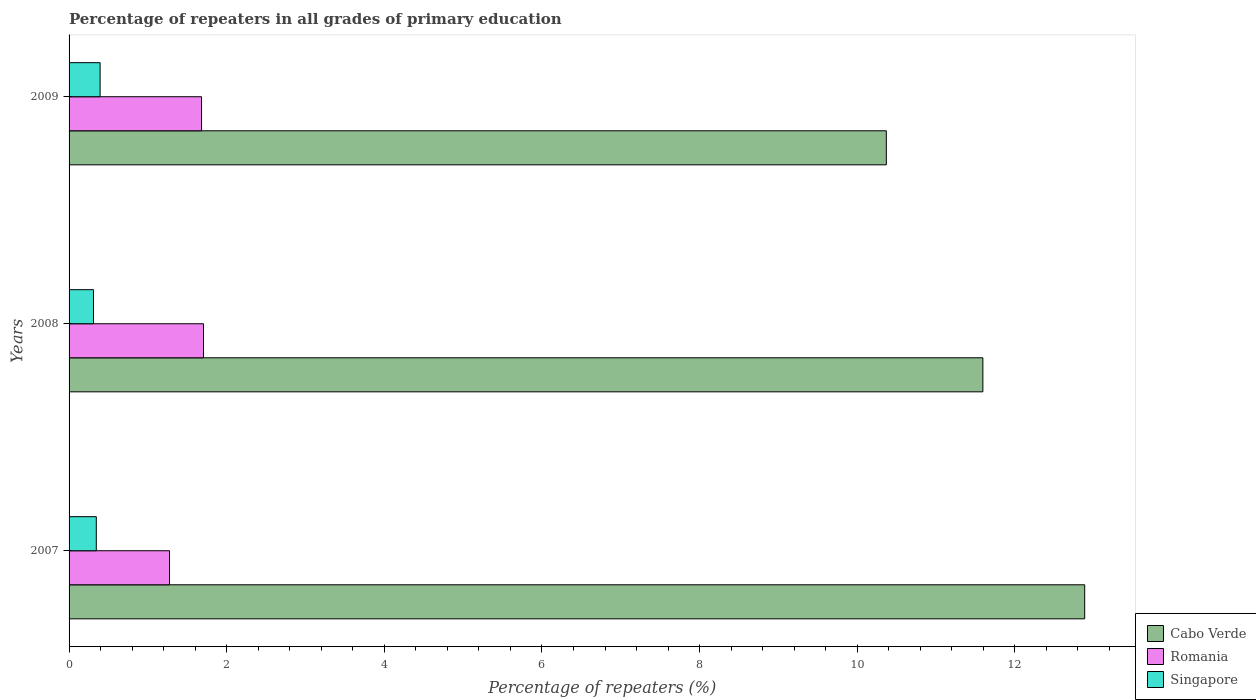How many different coloured bars are there?
Your answer should be compact. 3. How many bars are there on the 2nd tick from the top?
Provide a succinct answer. 3. In how many cases, is the number of bars for a given year not equal to the number of legend labels?
Provide a succinct answer. 0. What is the percentage of repeaters in Romania in 2007?
Provide a short and direct response. 1.27. Across all years, what is the maximum percentage of repeaters in Romania?
Offer a very short reply. 1.71. Across all years, what is the minimum percentage of repeaters in Romania?
Make the answer very short. 1.27. In which year was the percentage of repeaters in Romania maximum?
Offer a very short reply. 2008. In which year was the percentage of repeaters in Singapore minimum?
Offer a terse response. 2008. What is the total percentage of repeaters in Cabo Verde in the graph?
Offer a terse response. 34.85. What is the difference between the percentage of repeaters in Cabo Verde in 2008 and that in 2009?
Your answer should be very brief. 1.23. What is the difference between the percentage of repeaters in Singapore in 2009 and the percentage of repeaters in Cabo Verde in 2007?
Make the answer very short. -12.49. What is the average percentage of repeaters in Romania per year?
Offer a terse response. 1.55. In the year 2008, what is the difference between the percentage of repeaters in Cabo Verde and percentage of repeaters in Singapore?
Ensure brevity in your answer.  11.28. In how many years, is the percentage of repeaters in Cabo Verde greater than 11.2 %?
Ensure brevity in your answer.  2. What is the ratio of the percentage of repeaters in Romania in 2007 to that in 2009?
Keep it short and to the point. 0.76. Is the percentage of repeaters in Cabo Verde in 2007 less than that in 2008?
Your response must be concise. No. What is the difference between the highest and the second highest percentage of repeaters in Cabo Verde?
Your answer should be very brief. 1.29. What is the difference between the highest and the lowest percentage of repeaters in Romania?
Give a very brief answer. 0.43. Is the sum of the percentage of repeaters in Singapore in 2008 and 2009 greater than the maximum percentage of repeaters in Cabo Verde across all years?
Your answer should be compact. No. What does the 1st bar from the top in 2008 represents?
Your response must be concise. Singapore. What does the 3rd bar from the bottom in 2009 represents?
Offer a terse response. Singapore. Are all the bars in the graph horizontal?
Provide a short and direct response. Yes. What is the difference between two consecutive major ticks on the X-axis?
Keep it short and to the point. 2. Are the values on the major ticks of X-axis written in scientific E-notation?
Offer a very short reply. No. Does the graph contain any zero values?
Provide a succinct answer. No. How many legend labels are there?
Your answer should be very brief. 3. How are the legend labels stacked?
Your answer should be compact. Vertical. What is the title of the graph?
Provide a short and direct response. Percentage of repeaters in all grades of primary education. Does "Pakistan" appear as one of the legend labels in the graph?
Keep it short and to the point. No. What is the label or title of the X-axis?
Give a very brief answer. Percentage of repeaters (%). What is the label or title of the Y-axis?
Ensure brevity in your answer.  Years. What is the Percentage of repeaters (%) in Cabo Verde in 2007?
Your response must be concise. 12.89. What is the Percentage of repeaters (%) in Romania in 2007?
Your response must be concise. 1.27. What is the Percentage of repeaters (%) in Singapore in 2007?
Give a very brief answer. 0.35. What is the Percentage of repeaters (%) in Cabo Verde in 2008?
Offer a terse response. 11.59. What is the Percentage of repeaters (%) in Romania in 2008?
Ensure brevity in your answer.  1.71. What is the Percentage of repeaters (%) in Singapore in 2008?
Offer a very short reply. 0.31. What is the Percentage of repeaters (%) in Cabo Verde in 2009?
Provide a succinct answer. 10.37. What is the Percentage of repeaters (%) in Romania in 2009?
Keep it short and to the point. 1.68. What is the Percentage of repeaters (%) of Singapore in 2009?
Your answer should be very brief. 0.39. Across all years, what is the maximum Percentage of repeaters (%) of Cabo Verde?
Your answer should be compact. 12.89. Across all years, what is the maximum Percentage of repeaters (%) of Romania?
Offer a very short reply. 1.71. Across all years, what is the maximum Percentage of repeaters (%) of Singapore?
Give a very brief answer. 0.39. Across all years, what is the minimum Percentage of repeaters (%) in Cabo Verde?
Your answer should be very brief. 10.37. Across all years, what is the minimum Percentage of repeaters (%) in Romania?
Offer a very short reply. 1.27. Across all years, what is the minimum Percentage of repeaters (%) of Singapore?
Provide a short and direct response. 0.31. What is the total Percentage of repeaters (%) of Cabo Verde in the graph?
Offer a terse response. 34.85. What is the total Percentage of repeaters (%) in Romania in the graph?
Provide a succinct answer. 4.66. What is the total Percentage of repeaters (%) of Singapore in the graph?
Keep it short and to the point. 1.05. What is the difference between the Percentage of repeaters (%) in Cabo Verde in 2007 and that in 2008?
Ensure brevity in your answer.  1.29. What is the difference between the Percentage of repeaters (%) of Romania in 2007 and that in 2008?
Ensure brevity in your answer.  -0.43. What is the difference between the Percentage of repeaters (%) in Singapore in 2007 and that in 2008?
Your answer should be very brief. 0.04. What is the difference between the Percentage of repeaters (%) in Cabo Verde in 2007 and that in 2009?
Provide a short and direct response. 2.52. What is the difference between the Percentage of repeaters (%) of Romania in 2007 and that in 2009?
Offer a terse response. -0.41. What is the difference between the Percentage of repeaters (%) of Singapore in 2007 and that in 2009?
Offer a very short reply. -0.05. What is the difference between the Percentage of repeaters (%) in Cabo Verde in 2008 and that in 2009?
Provide a short and direct response. 1.23. What is the difference between the Percentage of repeaters (%) in Romania in 2008 and that in 2009?
Keep it short and to the point. 0.02. What is the difference between the Percentage of repeaters (%) of Singapore in 2008 and that in 2009?
Keep it short and to the point. -0.08. What is the difference between the Percentage of repeaters (%) of Cabo Verde in 2007 and the Percentage of repeaters (%) of Romania in 2008?
Provide a succinct answer. 11.18. What is the difference between the Percentage of repeaters (%) in Cabo Verde in 2007 and the Percentage of repeaters (%) in Singapore in 2008?
Provide a succinct answer. 12.58. What is the difference between the Percentage of repeaters (%) of Romania in 2007 and the Percentage of repeaters (%) of Singapore in 2008?
Keep it short and to the point. 0.96. What is the difference between the Percentage of repeaters (%) in Cabo Verde in 2007 and the Percentage of repeaters (%) in Romania in 2009?
Keep it short and to the point. 11.2. What is the difference between the Percentage of repeaters (%) of Cabo Verde in 2007 and the Percentage of repeaters (%) of Singapore in 2009?
Keep it short and to the point. 12.49. What is the difference between the Percentage of repeaters (%) in Romania in 2007 and the Percentage of repeaters (%) in Singapore in 2009?
Provide a short and direct response. 0.88. What is the difference between the Percentage of repeaters (%) of Cabo Verde in 2008 and the Percentage of repeaters (%) of Romania in 2009?
Make the answer very short. 9.91. What is the difference between the Percentage of repeaters (%) of Cabo Verde in 2008 and the Percentage of repeaters (%) of Singapore in 2009?
Provide a succinct answer. 11.2. What is the difference between the Percentage of repeaters (%) in Romania in 2008 and the Percentage of repeaters (%) in Singapore in 2009?
Ensure brevity in your answer.  1.31. What is the average Percentage of repeaters (%) of Cabo Verde per year?
Ensure brevity in your answer.  11.62. What is the average Percentage of repeaters (%) of Romania per year?
Ensure brevity in your answer.  1.55. What is the average Percentage of repeaters (%) of Singapore per year?
Make the answer very short. 0.35. In the year 2007, what is the difference between the Percentage of repeaters (%) of Cabo Verde and Percentage of repeaters (%) of Romania?
Offer a very short reply. 11.61. In the year 2007, what is the difference between the Percentage of repeaters (%) of Cabo Verde and Percentage of repeaters (%) of Singapore?
Keep it short and to the point. 12.54. In the year 2007, what is the difference between the Percentage of repeaters (%) in Romania and Percentage of repeaters (%) in Singapore?
Ensure brevity in your answer.  0.93. In the year 2008, what is the difference between the Percentage of repeaters (%) in Cabo Verde and Percentage of repeaters (%) in Romania?
Provide a short and direct response. 9.89. In the year 2008, what is the difference between the Percentage of repeaters (%) of Cabo Verde and Percentage of repeaters (%) of Singapore?
Offer a very short reply. 11.28. In the year 2008, what is the difference between the Percentage of repeaters (%) of Romania and Percentage of repeaters (%) of Singapore?
Make the answer very short. 1.4. In the year 2009, what is the difference between the Percentage of repeaters (%) in Cabo Verde and Percentage of repeaters (%) in Romania?
Keep it short and to the point. 8.69. In the year 2009, what is the difference between the Percentage of repeaters (%) of Cabo Verde and Percentage of repeaters (%) of Singapore?
Provide a short and direct response. 9.97. In the year 2009, what is the difference between the Percentage of repeaters (%) in Romania and Percentage of repeaters (%) in Singapore?
Offer a terse response. 1.29. What is the ratio of the Percentage of repeaters (%) of Cabo Verde in 2007 to that in 2008?
Ensure brevity in your answer.  1.11. What is the ratio of the Percentage of repeaters (%) of Romania in 2007 to that in 2008?
Ensure brevity in your answer.  0.75. What is the ratio of the Percentage of repeaters (%) of Singapore in 2007 to that in 2008?
Provide a succinct answer. 1.12. What is the ratio of the Percentage of repeaters (%) of Cabo Verde in 2007 to that in 2009?
Offer a very short reply. 1.24. What is the ratio of the Percentage of repeaters (%) of Romania in 2007 to that in 2009?
Provide a short and direct response. 0.76. What is the ratio of the Percentage of repeaters (%) in Singapore in 2007 to that in 2009?
Your response must be concise. 0.88. What is the ratio of the Percentage of repeaters (%) of Cabo Verde in 2008 to that in 2009?
Your answer should be very brief. 1.12. What is the ratio of the Percentage of repeaters (%) of Romania in 2008 to that in 2009?
Your response must be concise. 1.01. What is the ratio of the Percentage of repeaters (%) in Singapore in 2008 to that in 2009?
Make the answer very short. 0.79. What is the difference between the highest and the second highest Percentage of repeaters (%) in Cabo Verde?
Your answer should be compact. 1.29. What is the difference between the highest and the second highest Percentage of repeaters (%) in Romania?
Keep it short and to the point. 0.02. What is the difference between the highest and the second highest Percentage of repeaters (%) in Singapore?
Your answer should be compact. 0.05. What is the difference between the highest and the lowest Percentage of repeaters (%) of Cabo Verde?
Keep it short and to the point. 2.52. What is the difference between the highest and the lowest Percentage of repeaters (%) of Romania?
Give a very brief answer. 0.43. What is the difference between the highest and the lowest Percentage of repeaters (%) of Singapore?
Your answer should be very brief. 0.08. 